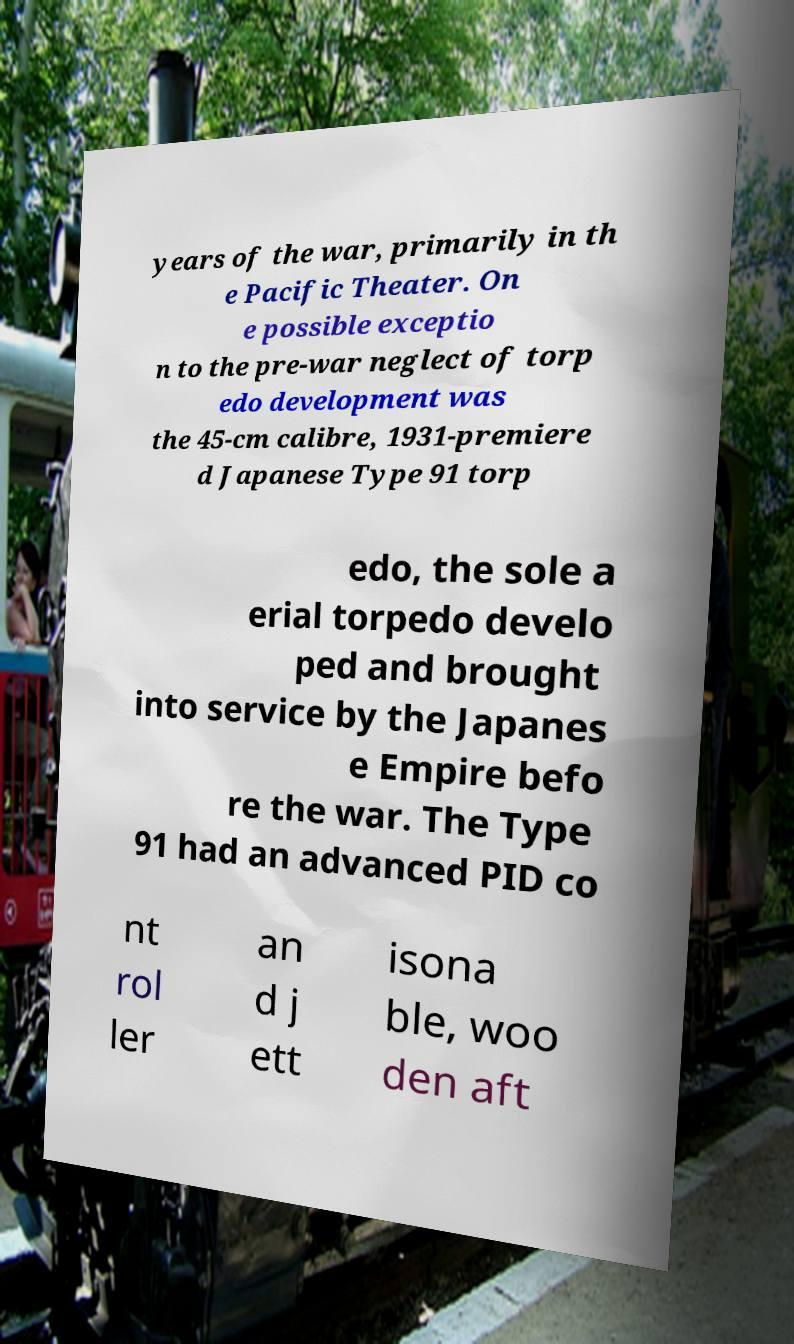Can you accurately transcribe the text from the provided image for me? years of the war, primarily in th e Pacific Theater. On e possible exceptio n to the pre-war neglect of torp edo development was the 45-cm calibre, 1931-premiere d Japanese Type 91 torp edo, the sole a erial torpedo develo ped and brought into service by the Japanes e Empire befo re the war. The Type 91 had an advanced PID co nt rol ler an d j ett isona ble, woo den aft 